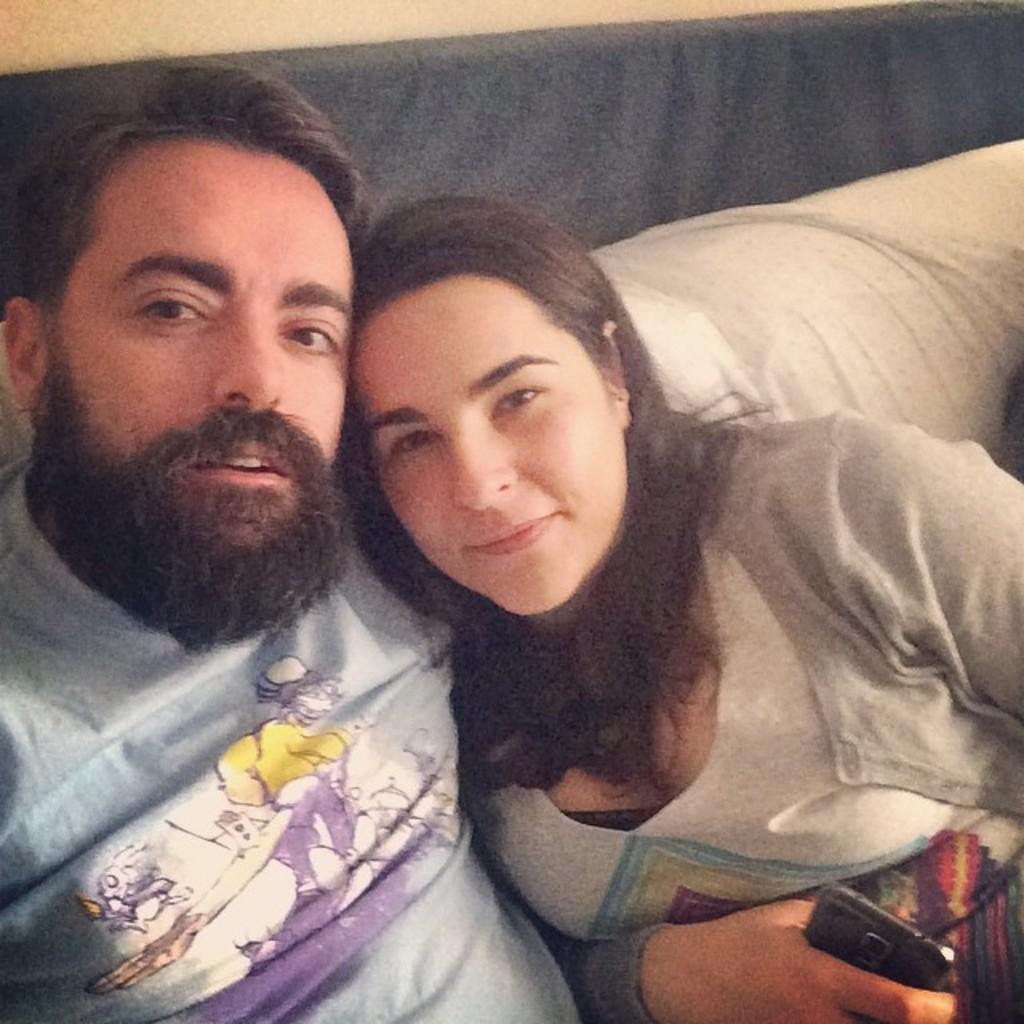Can you describe this image briefly? In the picture we can see a man and a woman sitting together on the sofa which is white in color and man is with beards and a woman is holding a mobile phone in the hand and in the background we can see a wall with some black color plank to it. 